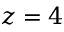<formula> <loc_0><loc_0><loc_500><loc_500>z = 4</formula> 